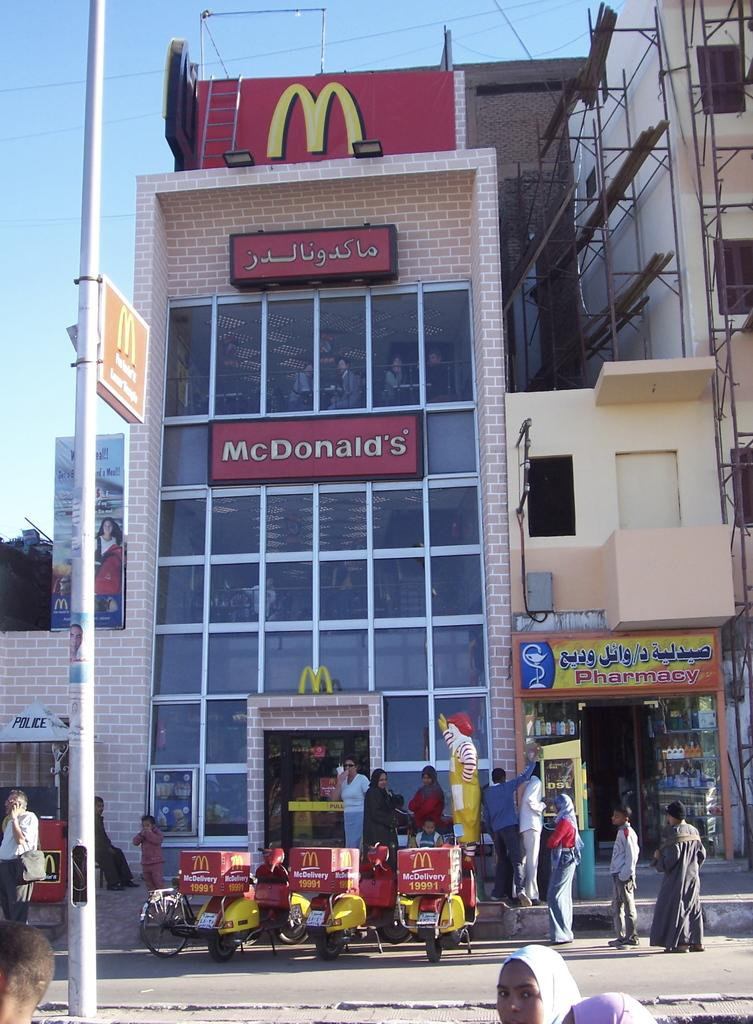<image>
Describe the image concisely. People are standing outside the McDonald's and pharmacy. 